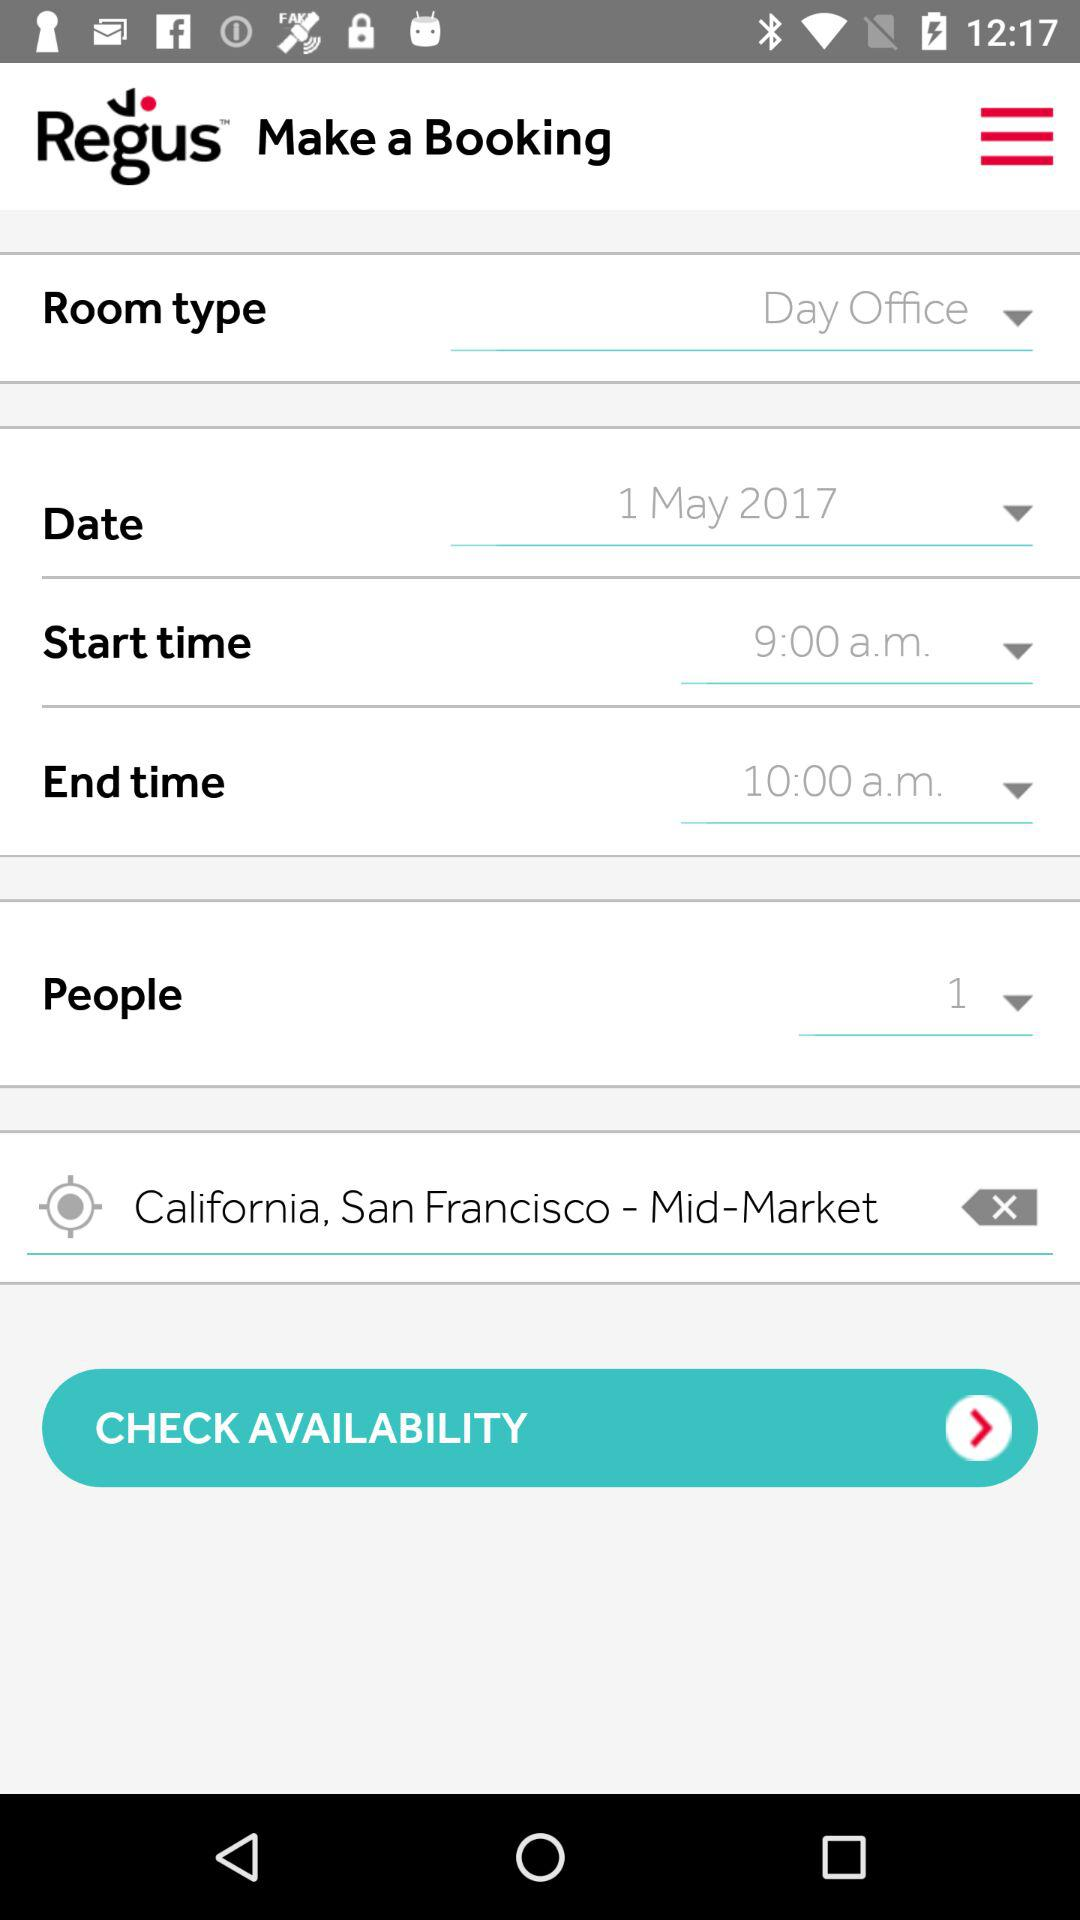How many people are there? There is one person. 